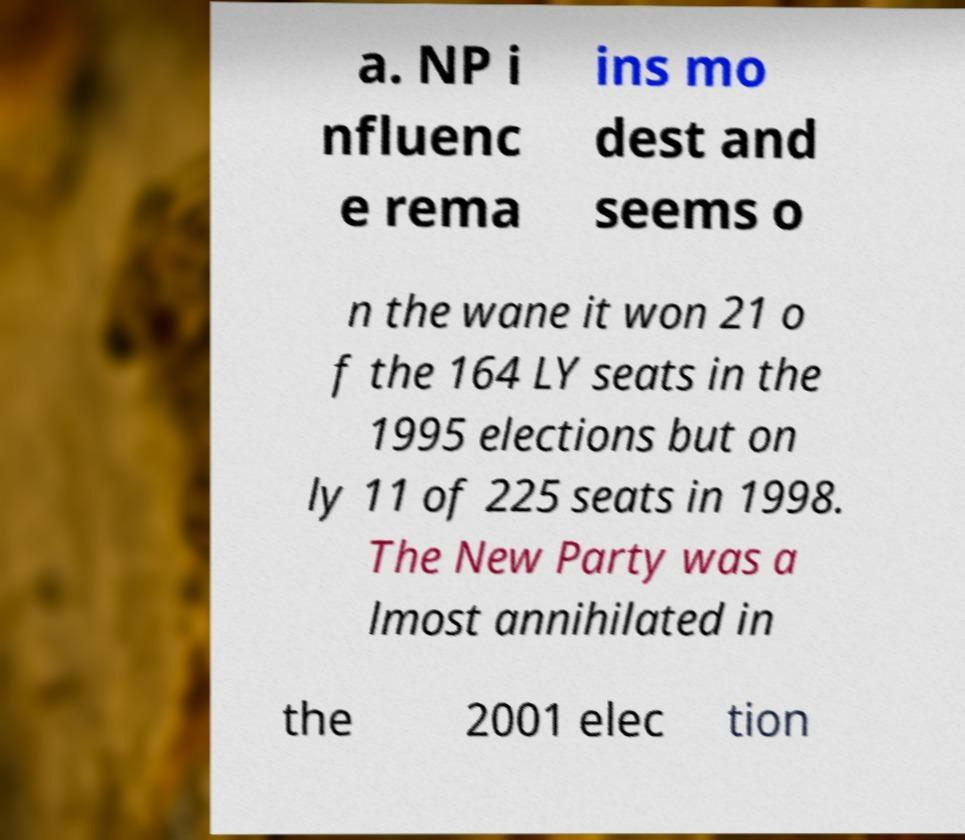There's text embedded in this image that I need extracted. Can you transcribe it verbatim? a. NP i nfluenc e rema ins mo dest and seems o n the wane it won 21 o f the 164 LY seats in the 1995 elections but on ly 11 of 225 seats in 1998. The New Party was a lmost annihilated in the 2001 elec tion 